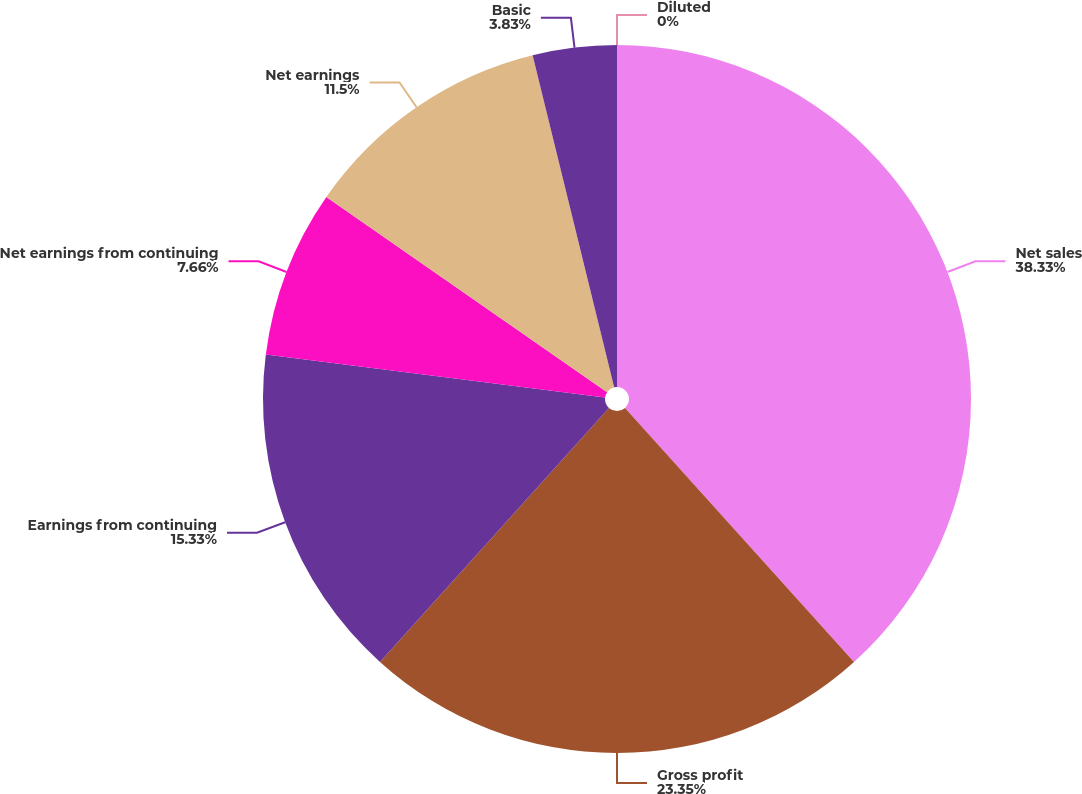Convert chart to OTSL. <chart><loc_0><loc_0><loc_500><loc_500><pie_chart><fcel>Net sales<fcel>Gross profit<fcel>Earnings from continuing<fcel>Net earnings from continuing<fcel>Net earnings<fcel>Basic<fcel>Diluted<nl><fcel>38.32%<fcel>23.35%<fcel>15.33%<fcel>7.66%<fcel>11.5%<fcel>3.83%<fcel>0.0%<nl></chart> 